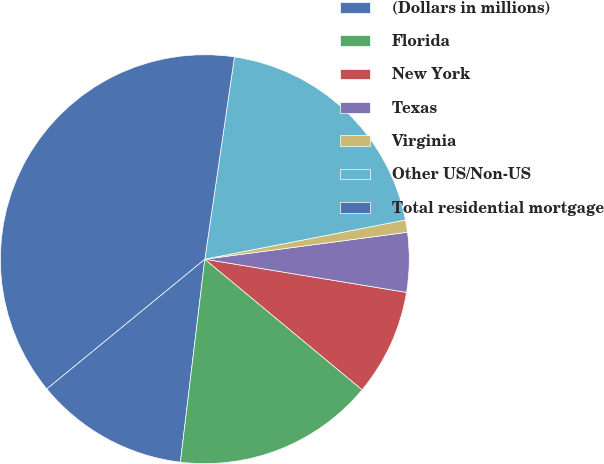Convert chart. <chart><loc_0><loc_0><loc_500><loc_500><pie_chart><fcel>(Dollars in millions)<fcel>Florida<fcel>New York<fcel>Texas<fcel>Virginia<fcel>Other US/Non-US<fcel>Total residential mortgage<nl><fcel>12.16%<fcel>15.88%<fcel>8.43%<fcel>4.7%<fcel>0.97%<fcel>19.61%<fcel>38.25%<nl></chart> 